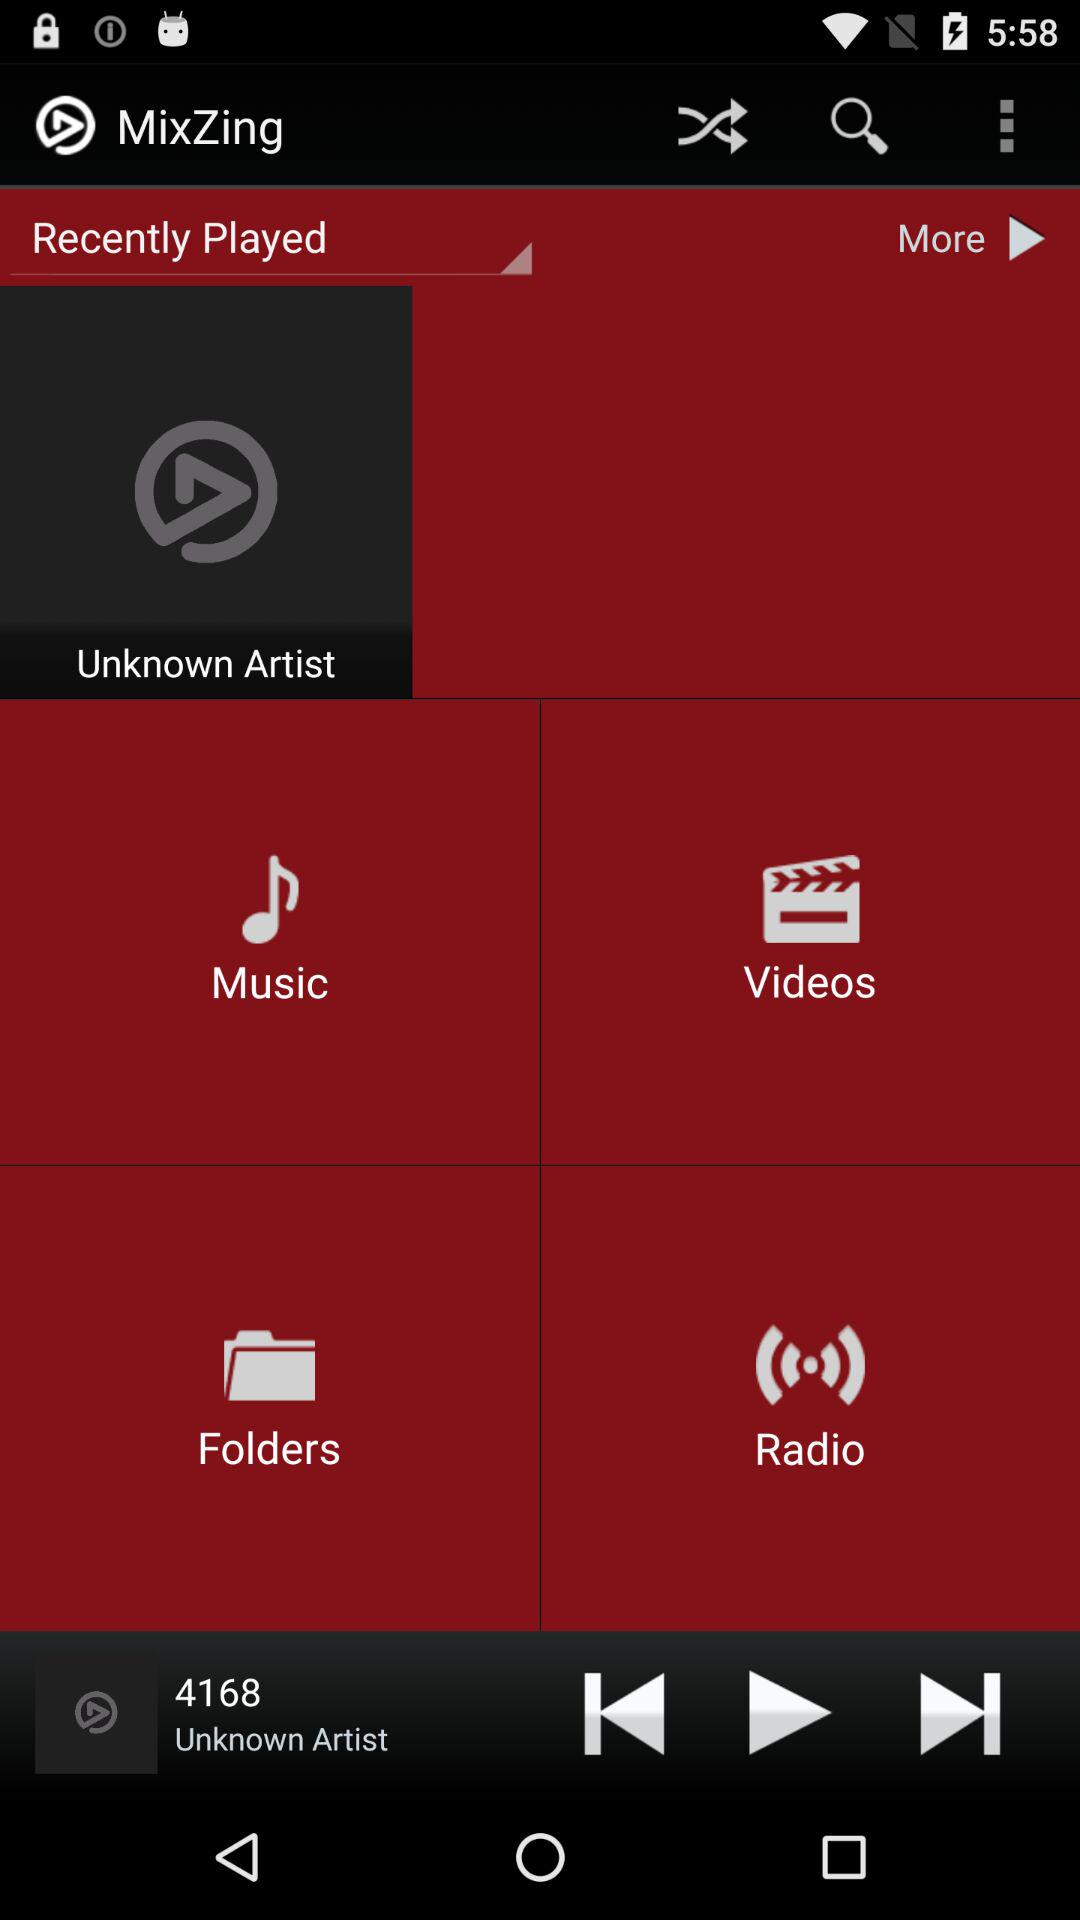What is the duration of "4168"?
When the provided information is insufficient, respond with <no answer>. <no answer> 